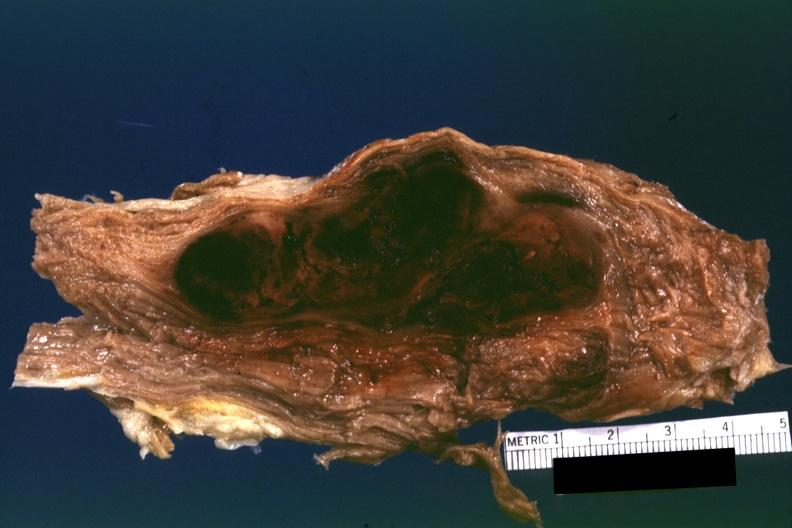does not truly normal ovaries need to be changed?
Answer the question using a single word or phrase. No 